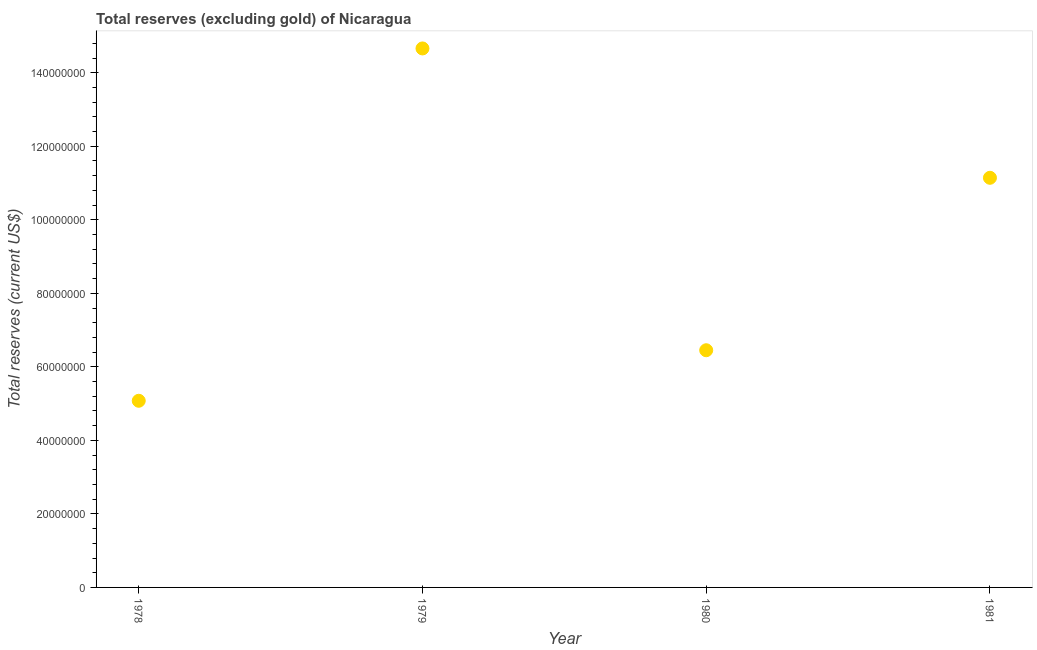What is the total reserves (excluding gold) in 1981?
Your answer should be compact. 1.11e+08. Across all years, what is the maximum total reserves (excluding gold)?
Your answer should be compact. 1.47e+08. Across all years, what is the minimum total reserves (excluding gold)?
Your answer should be compact. 5.08e+07. In which year was the total reserves (excluding gold) maximum?
Keep it short and to the point. 1979. In which year was the total reserves (excluding gold) minimum?
Your answer should be compact. 1978. What is the sum of the total reserves (excluding gold)?
Give a very brief answer. 3.73e+08. What is the difference between the total reserves (excluding gold) in 1979 and 1981?
Offer a terse response. 3.52e+07. What is the average total reserves (excluding gold) per year?
Offer a terse response. 9.33e+07. What is the median total reserves (excluding gold)?
Your response must be concise. 8.80e+07. In how many years, is the total reserves (excluding gold) greater than 24000000 US$?
Provide a succinct answer. 4. What is the ratio of the total reserves (excluding gold) in 1978 to that in 1981?
Provide a short and direct response. 0.46. Is the difference between the total reserves (excluding gold) in 1978 and 1979 greater than the difference between any two years?
Give a very brief answer. Yes. What is the difference between the highest and the second highest total reserves (excluding gold)?
Your answer should be very brief. 3.52e+07. What is the difference between the highest and the lowest total reserves (excluding gold)?
Keep it short and to the point. 9.58e+07. In how many years, is the total reserves (excluding gold) greater than the average total reserves (excluding gold) taken over all years?
Ensure brevity in your answer.  2. Does the total reserves (excluding gold) monotonically increase over the years?
Your answer should be very brief. No. How many dotlines are there?
Provide a short and direct response. 1. What is the difference between two consecutive major ticks on the Y-axis?
Give a very brief answer. 2.00e+07. Are the values on the major ticks of Y-axis written in scientific E-notation?
Your response must be concise. No. Does the graph contain grids?
Keep it short and to the point. No. What is the title of the graph?
Keep it short and to the point. Total reserves (excluding gold) of Nicaragua. What is the label or title of the X-axis?
Make the answer very short. Year. What is the label or title of the Y-axis?
Your answer should be compact. Total reserves (current US$). What is the Total reserves (current US$) in 1978?
Provide a succinct answer. 5.08e+07. What is the Total reserves (current US$) in 1979?
Give a very brief answer. 1.47e+08. What is the Total reserves (current US$) in 1980?
Your answer should be very brief. 6.45e+07. What is the Total reserves (current US$) in 1981?
Provide a short and direct response. 1.11e+08. What is the difference between the Total reserves (current US$) in 1978 and 1979?
Offer a very short reply. -9.58e+07. What is the difference between the Total reserves (current US$) in 1978 and 1980?
Make the answer very short. -1.37e+07. What is the difference between the Total reserves (current US$) in 1978 and 1981?
Your response must be concise. -6.07e+07. What is the difference between the Total reserves (current US$) in 1979 and 1980?
Offer a terse response. 8.21e+07. What is the difference between the Total reserves (current US$) in 1979 and 1981?
Provide a succinct answer. 3.52e+07. What is the difference between the Total reserves (current US$) in 1980 and 1981?
Make the answer very short. -4.69e+07. What is the ratio of the Total reserves (current US$) in 1978 to that in 1979?
Keep it short and to the point. 0.35. What is the ratio of the Total reserves (current US$) in 1978 to that in 1980?
Give a very brief answer. 0.79. What is the ratio of the Total reserves (current US$) in 1978 to that in 1981?
Make the answer very short. 0.46. What is the ratio of the Total reserves (current US$) in 1979 to that in 1980?
Your answer should be very brief. 2.27. What is the ratio of the Total reserves (current US$) in 1979 to that in 1981?
Offer a terse response. 1.32. What is the ratio of the Total reserves (current US$) in 1980 to that in 1981?
Provide a succinct answer. 0.58. 